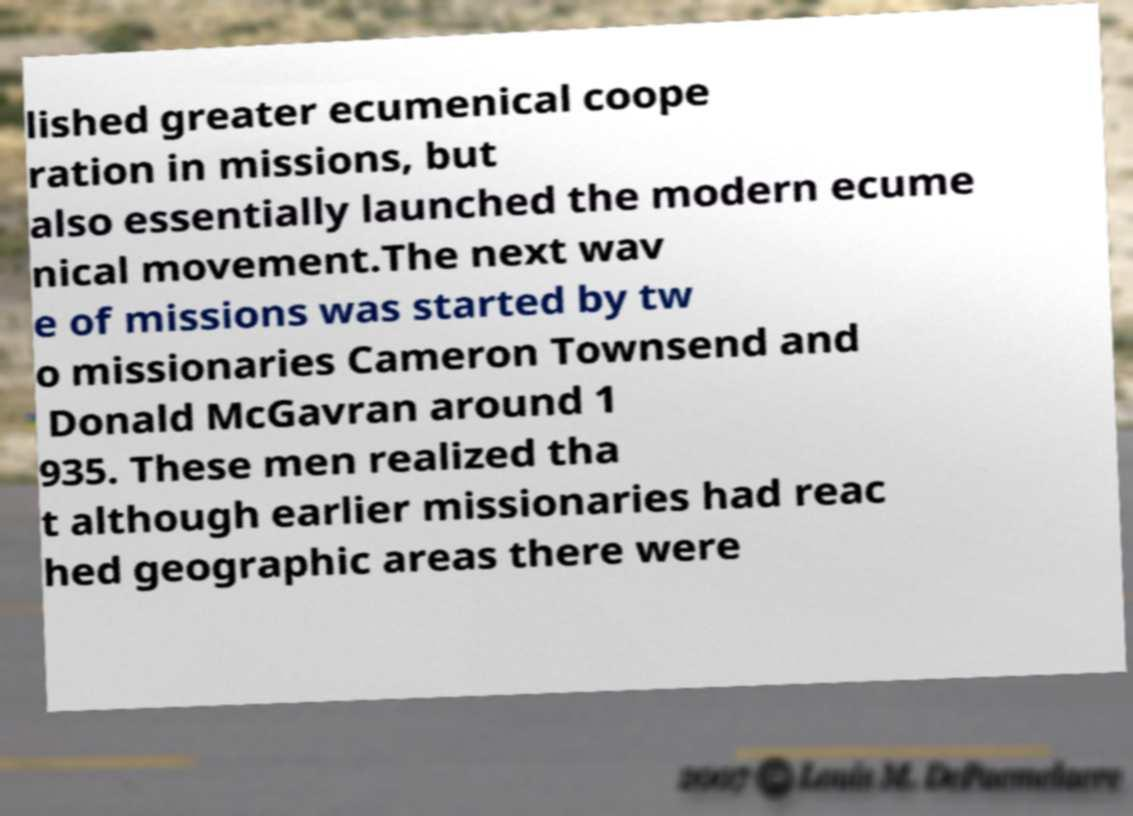Please identify and transcribe the text found in this image. lished greater ecumenical coope ration in missions, but also essentially launched the modern ecume nical movement.The next wav e of missions was started by tw o missionaries Cameron Townsend and Donald McGavran around 1 935. These men realized tha t although earlier missionaries had reac hed geographic areas there were 